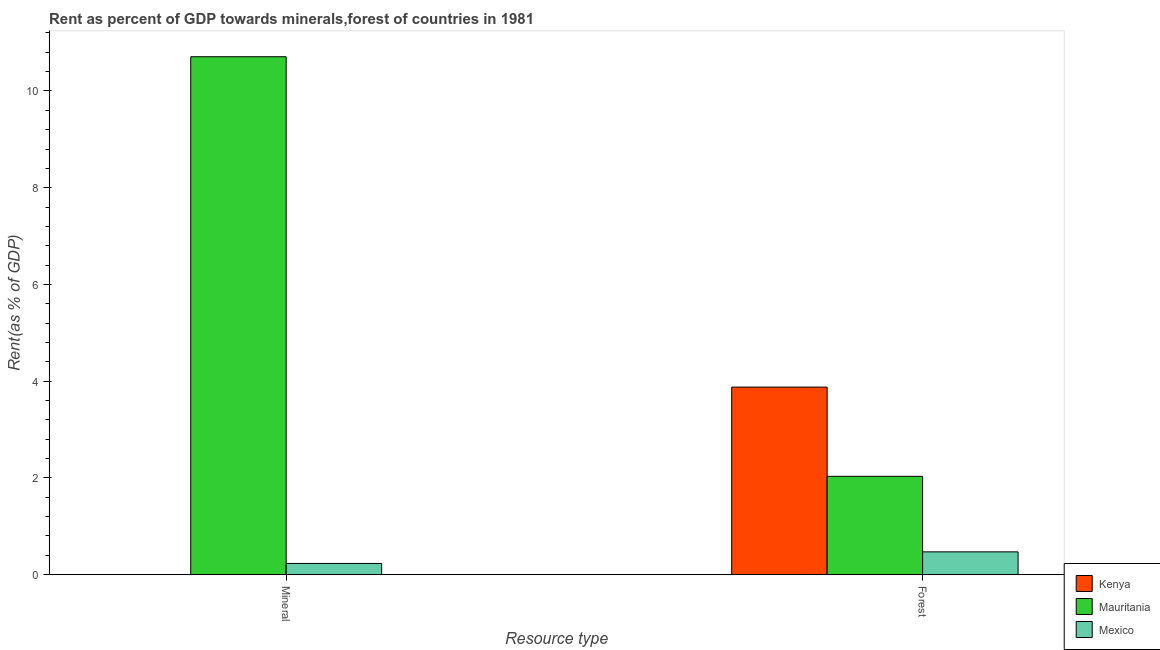Are the number of bars per tick equal to the number of legend labels?
Give a very brief answer. Yes. Are the number of bars on each tick of the X-axis equal?
Provide a succinct answer. Yes. How many bars are there on the 1st tick from the right?
Provide a short and direct response. 3. What is the label of the 1st group of bars from the left?
Your answer should be very brief. Mineral. What is the forest rent in Mexico?
Make the answer very short. 0.47. Across all countries, what is the maximum forest rent?
Your response must be concise. 3.88. Across all countries, what is the minimum mineral rent?
Your response must be concise. 9.89683064769055e-5. In which country was the forest rent maximum?
Make the answer very short. Kenya. In which country was the forest rent minimum?
Provide a short and direct response. Mexico. What is the total forest rent in the graph?
Offer a very short reply. 6.38. What is the difference between the forest rent in Mexico and that in Mauritania?
Provide a short and direct response. -1.56. What is the difference between the mineral rent in Mauritania and the forest rent in Kenya?
Provide a short and direct response. 6.83. What is the average mineral rent per country?
Provide a short and direct response. 3.65. What is the difference between the forest rent and mineral rent in Mauritania?
Give a very brief answer. -8.67. In how many countries, is the mineral rent greater than 8 %?
Keep it short and to the point. 1. What is the ratio of the forest rent in Mauritania to that in Kenya?
Your answer should be compact. 0.52. In how many countries, is the forest rent greater than the average forest rent taken over all countries?
Give a very brief answer. 1. What does the 1st bar from the left in Forest represents?
Your response must be concise. Kenya. What does the 1st bar from the right in Mineral represents?
Ensure brevity in your answer.  Mexico. How many bars are there?
Make the answer very short. 6. Are all the bars in the graph horizontal?
Your answer should be compact. No. Does the graph contain any zero values?
Your answer should be compact. No. Does the graph contain grids?
Keep it short and to the point. No. How many legend labels are there?
Ensure brevity in your answer.  3. How are the legend labels stacked?
Your answer should be compact. Vertical. What is the title of the graph?
Provide a succinct answer. Rent as percent of GDP towards minerals,forest of countries in 1981. What is the label or title of the X-axis?
Make the answer very short. Resource type. What is the label or title of the Y-axis?
Provide a short and direct response. Rent(as % of GDP). What is the Rent(as % of GDP) in Kenya in Mineral?
Keep it short and to the point. 9.89683064769055e-5. What is the Rent(as % of GDP) of Mauritania in Mineral?
Ensure brevity in your answer.  10.71. What is the Rent(as % of GDP) in Mexico in Mineral?
Give a very brief answer. 0.23. What is the Rent(as % of GDP) in Kenya in Forest?
Your answer should be very brief. 3.88. What is the Rent(as % of GDP) of Mauritania in Forest?
Provide a succinct answer. 2.03. What is the Rent(as % of GDP) in Mexico in Forest?
Your response must be concise. 0.47. Across all Resource type, what is the maximum Rent(as % of GDP) of Kenya?
Keep it short and to the point. 3.88. Across all Resource type, what is the maximum Rent(as % of GDP) of Mauritania?
Your answer should be very brief. 10.71. Across all Resource type, what is the maximum Rent(as % of GDP) of Mexico?
Give a very brief answer. 0.47. Across all Resource type, what is the minimum Rent(as % of GDP) in Kenya?
Provide a succinct answer. 9.89683064769055e-5. Across all Resource type, what is the minimum Rent(as % of GDP) of Mauritania?
Make the answer very short. 2.03. Across all Resource type, what is the minimum Rent(as % of GDP) in Mexico?
Provide a succinct answer. 0.23. What is the total Rent(as % of GDP) in Kenya in the graph?
Give a very brief answer. 3.88. What is the total Rent(as % of GDP) of Mauritania in the graph?
Your answer should be very brief. 12.74. What is the total Rent(as % of GDP) of Mexico in the graph?
Offer a very short reply. 0.7. What is the difference between the Rent(as % of GDP) of Kenya in Mineral and that in Forest?
Your answer should be compact. -3.88. What is the difference between the Rent(as % of GDP) of Mauritania in Mineral and that in Forest?
Your response must be concise. 8.67. What is the difference between the Rent(as % of GDP) of Mexico in Mineral and that in Forest?
Your answer should be compact. -0.24. What is the difference between the Rent(as % of GDP) in Kenya in Mineral and the Rent(as % of GDP) in Mauritania in Forest?
Keep it short and to the point. -2.03. What is the difference between the Rent(as % of GDP) of Kenya in Mineral and the Rent(as % of GDP) of Mexico in Forest?
Ensure brevity in your answer.  -0.47. What is the difference between the Rent(as % of GDP) in Mauritania in Mineral and the Rent(as % of GDP) in Mexico in Forest?
Provide a succinct answer. 10.24. What is the average Rent(as % of GDP) of Kenya per Resource type?
Offer a terse response. 1.94. What is the average Rent(as % of GDP) in Mauritania per Resource type?
Your response must be concise. 6.37. What is the average Rent(as % of GDP) of Mexico per Resource type?
Keep it short and to the point. 0.35. What is the difference between the Rent(as % of GDP) of Kenya and Rent(as % of GDP) of Mauritania in Mineral?
Provide a succinct answer. -10.71. What is the difference between the Rent(as % of GDP) in Kenya and Rent(as % of GDP) in Mexico in Mineral?
Give a very brief answer. -0.23. What is the difference between the Rent(as % of GDP) of Mauritania and Rent(as % of GDP) of Mexico in Mineral?
Provide a succinct answer. 10.48. What is the difference between the Rent(as % of GDP) of Kenya and Rent(as % of GDP) of Mauritania in Forest?
Give a very brief answer. 1.84. What is the difference between the Rent(as % of GDP) of Kenya and Rent(as % of GDP) of Mexico in Forest?
Provide a succinct answer. 3.41. What is the difference between the Rent(as % of GDP) in Mauritania and Rent(as % of GDP) in Mexico in Forest?
Your response must be concise. 1.56. What is the ratio of the Rent(as % of GDP) in Mauritania in Mineral to that in Forest?
Make the answer very short. 5.27. What is the ratio of the Rent(as % of GDP) of Mexico in Mineral to that in Forest?
Your response must be concise. 0.49. What is the difference between the highest and the second highest Rent(as % of GDP) of Kenya?
Ensure brevity in your answer.  3.88. What is the difference between the highest and the second highest Rent(as % of GDP) of Mauritania?
Keep it short and to the point. 8.67. What is the difference between the highest and the second highest Rent(as % of GDP) of Mexico?
Offer a very short reply. 0.24. What is the difference between the highest and the lowest Rent(as % of GDP) of Kenya?
Your answer should be very brief. 3.88. What is the difference between the highest and the lowest Rent(as % of GDP) in Mauritania?
Your answer should be very brief. 8.67. What is the difference between the highest and the lowest Rent(as % of GDP) of Mexico?
Ensure brevity in your answer.  0.24. 